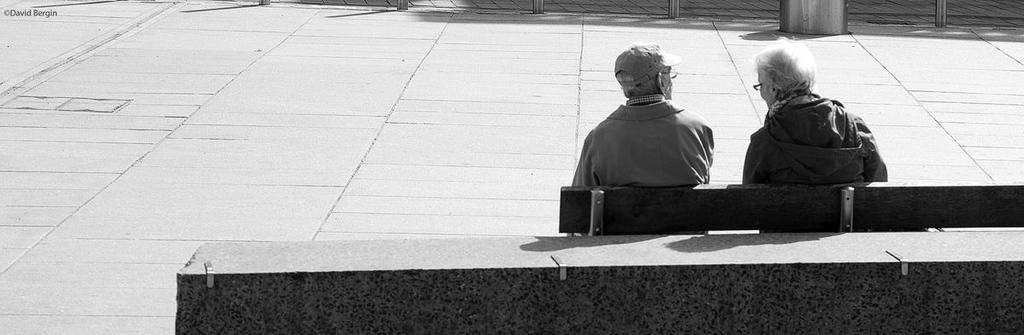What are the people in the image doing? The people in the image are sitting on a bench. What is the color scheme of the image? The image is in black and white color. What type of creature is sitting next to the people on the bench in the image? There is no creature present in the image; only people are sitting on the bench. What kind of badge can be seen on the people in the image? There is no badge visible on the people in the image, as it is in black and white color and no badges are mentioned in the provided facts. 